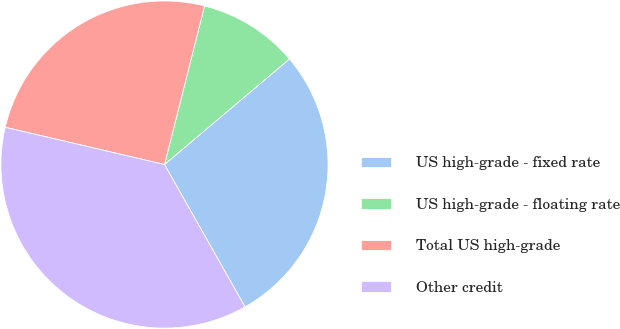Convert chart to OTSL. <chart><loc_0><loc_0><loc_500><loc_500><pie_chart><fcel>US high-grade - fixed rate<fcel>US high-grade - floating rate<fcel>Total US high-grade<fcel>Other credit<nl><fcel>27.97%<fcel>9.9%<fcel>25.28%<fcel>36.85%<nl></chart> 